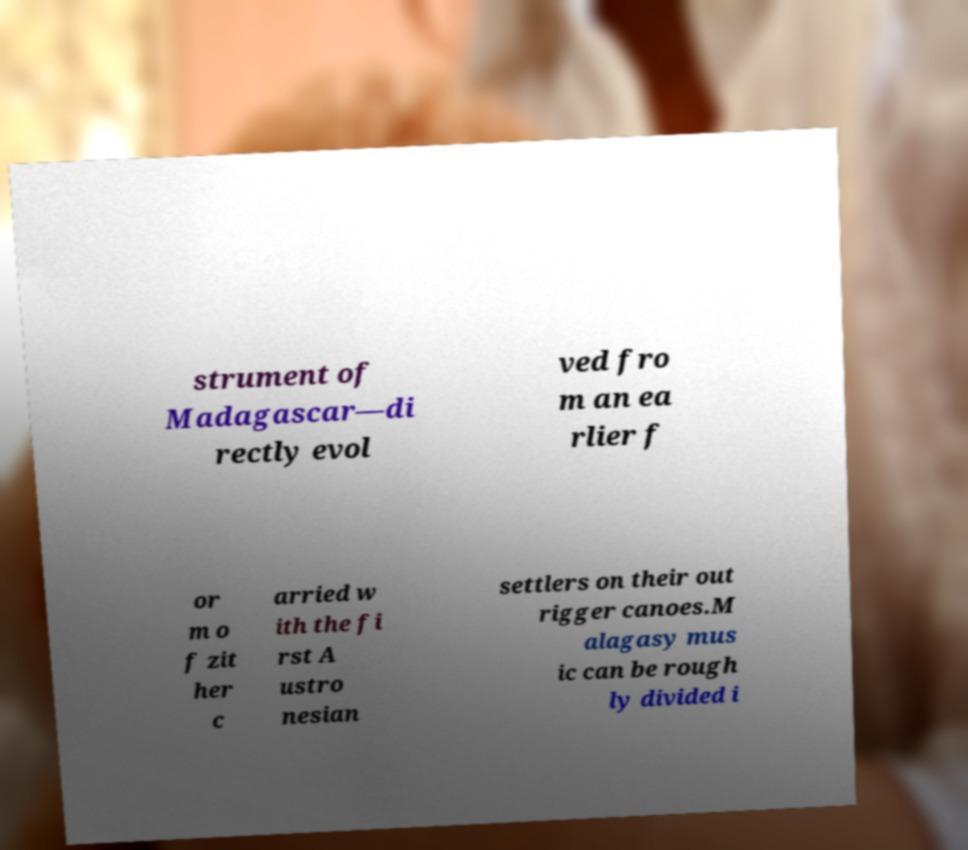Can you read and provide the text displayed in the image?This photo seems to have some interesting text. Can you extract and type it out for me? strument of Madagascar—di rectly evol ved fro m an ea rlier f or m o f zit her c arried w ith the fi rst A ustro nesian settlers on their out rigger canoes.M alagasy mus ic can be rough ly divided i 